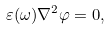Convert formula to latex. <formula><loc_0><loc_0><loc_500><loc_500>\varepsilon ( \omega ) \nabla ^ { 2 } \varphi = 0 ,</formula> 